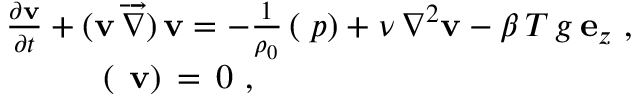<formula> <loc_0><loc_0><loc_500><loc_500>\begin{array} { r } { \frac { \partial { v } } { \partial t } + ( { v } \, \overrightarrow { \nabla } ) \, { v } = - \frac { 1 } { \rho _ { 0 } } \, ( { \nabla } { p } ) + \nu \, \nabla ^ { 2 } { v } - \beta \, T \, g \, { e } _ { z } \ , \quad } \\ { ( \nabla \, { v } ) \, = \, 0 \ , \quad } \end{array}</formula> 